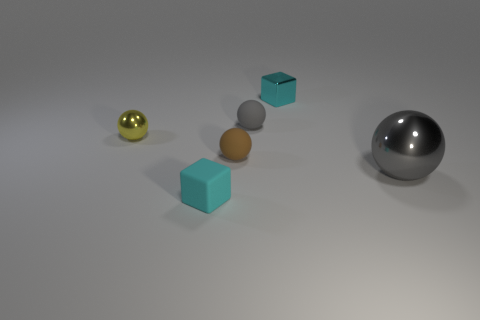Does the block behind the tiny yellow ball have the same material as the tiny cube on the left side of the brown object?
Provide a succinct answer. No. What is the tiny gray sphere made of?
Your response must be concise. Rubber. How many brown objects have the same shape as the cyan metallic object?
Keep it short and to the point. 0. There is another small cube that is the same color as the matte block; what is it made of?
Provide a short and direct response. Metal. Is there any other thing that is the same shape as the gray shiny object?
Your answer should be very brief. Yes. What color is the sphere that is to the left of the tiny block in front of the cyan cube behind the small cyan matte thing?
Make the answer very short. Yellow. How many big things are red shiny cubes or matte blocks?
Your answer should be compact. 0. Are there the same number of cyan cubes that are in front of the yellow sphere and tiny yellow balls?
Keep it short and to the point. Yes. Are there any big things behind the gray metallic thing?
Give a very brief answer. No. How many rubber objects are tiny brown balls or cubes?
Provide a succinct answer. 2. 